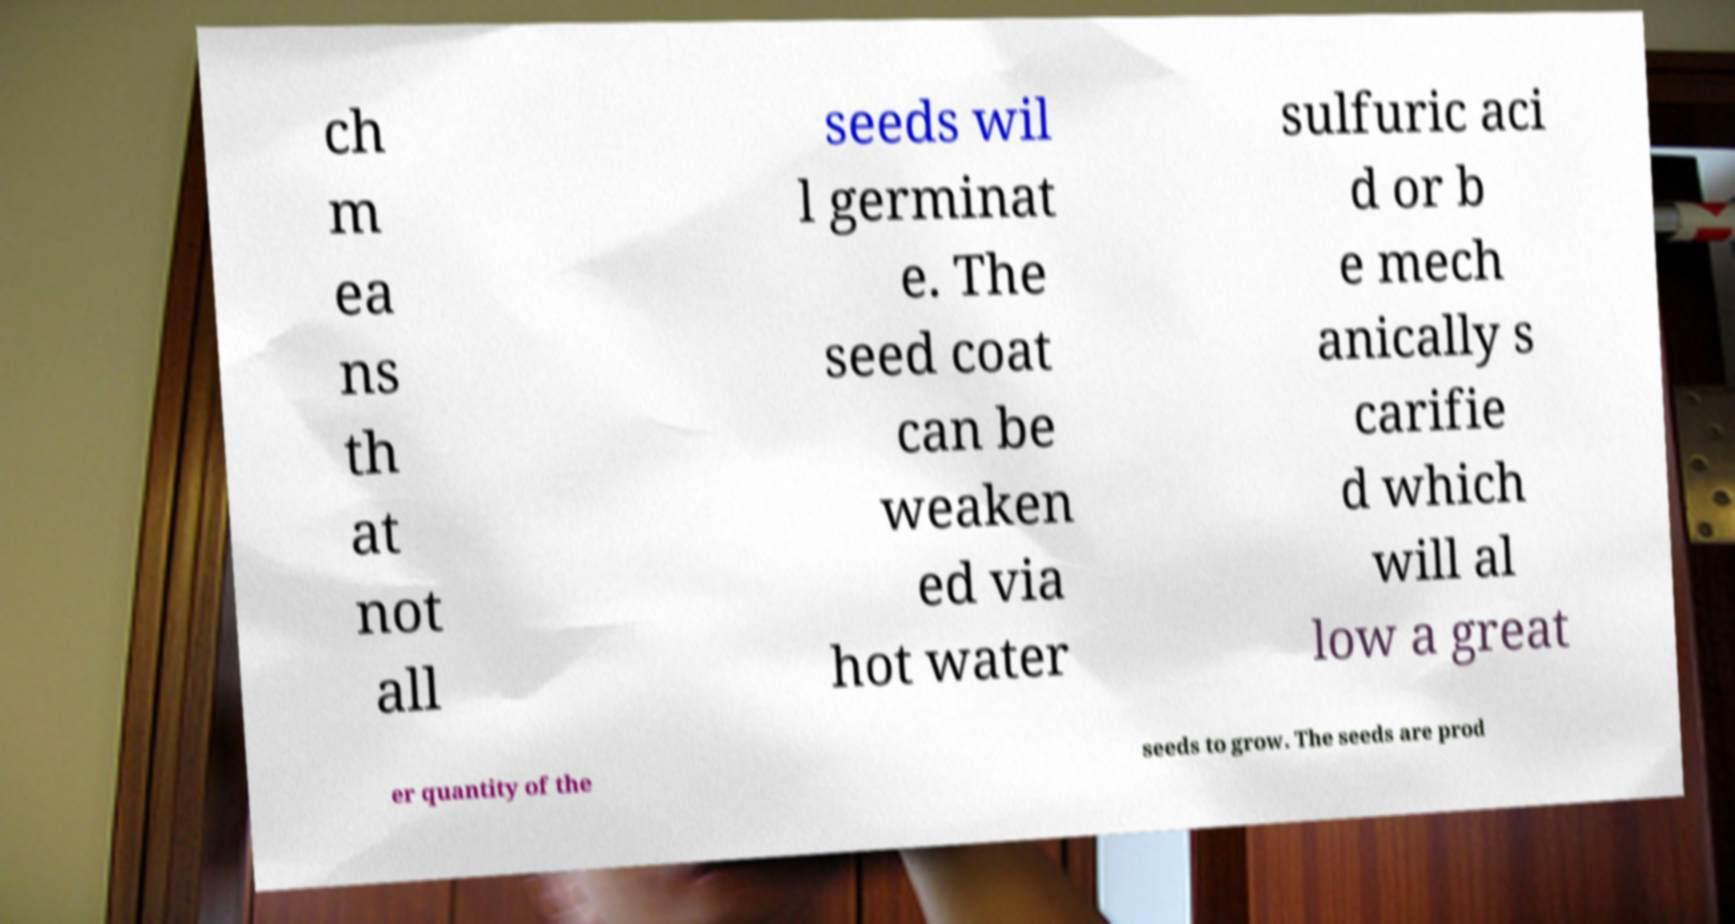What messages or text are displayed in this image? I need them in a readable, typed format. ch m ea ns th at not all seeds wil l germinat e. The seed coat can be weaken ed via hot water sulfuric aci d or b e mech anically s carifie d which will al low a great er quantity of the seeds to grow. The seeds are prod 